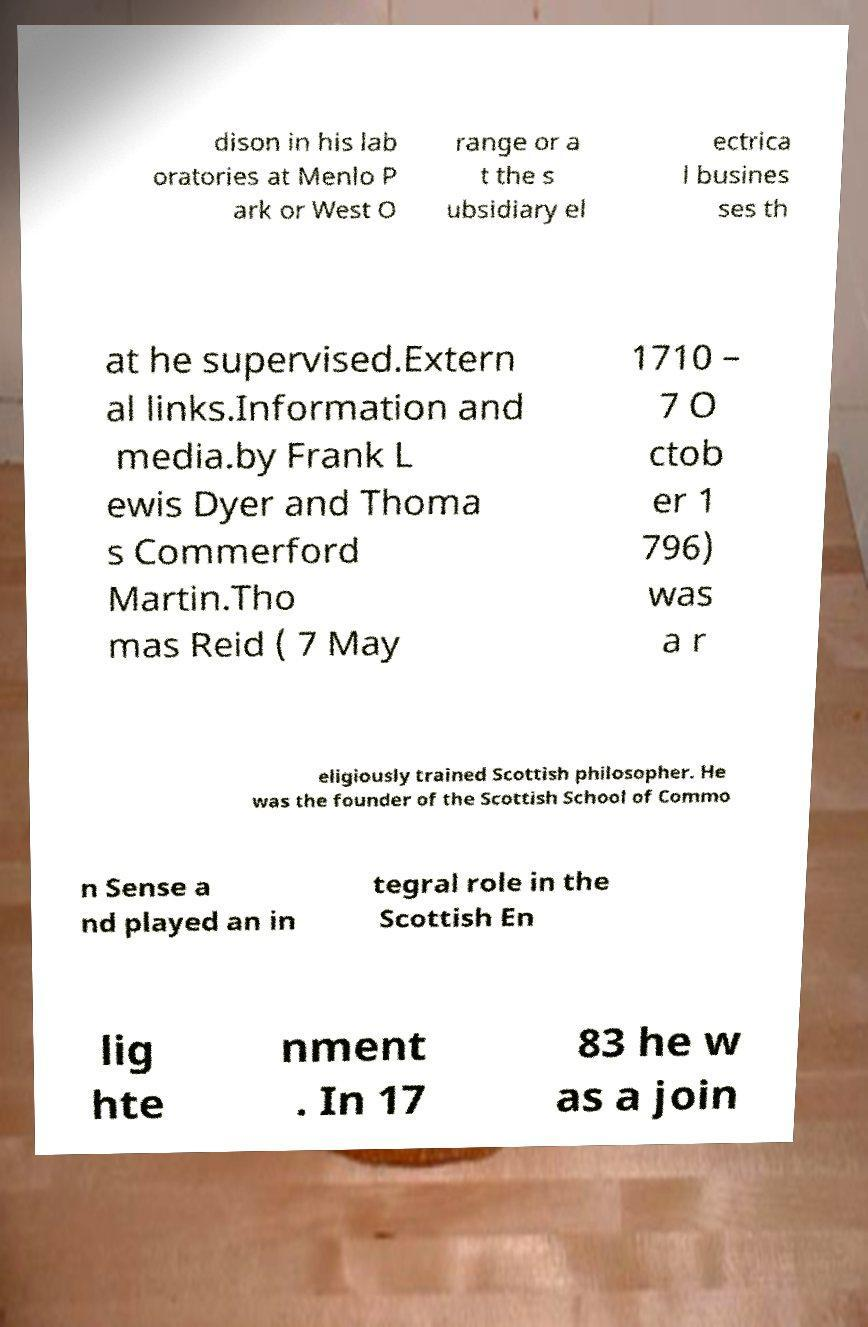Please identify and transcribe the text found in this image. dison in his lab oratories at Menlo P ark or West O range or a t the s ubsidiary el ectrica l busines ses th at he supervised.Extern al links.Information and media.by Frank L ewis Dyer and Thoma s Commerford Martin.Tho mas Reid ( 7 May 1710 – 7 O ctob er 1 796) was a r eligiously trained Scottish philosopher. He was the founder of the Scottish School of Commo n Sense a nd played an in tegral role in the Scottish En lig hte nment . In 17 83 he w as a join 